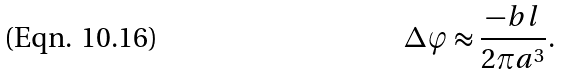<formula> <loc_0><loc_0><loc_500><loc_500>\Delta \varphi \approx \frac { - b l } { 2 \pi a ^ { 3 } } .</formula> 